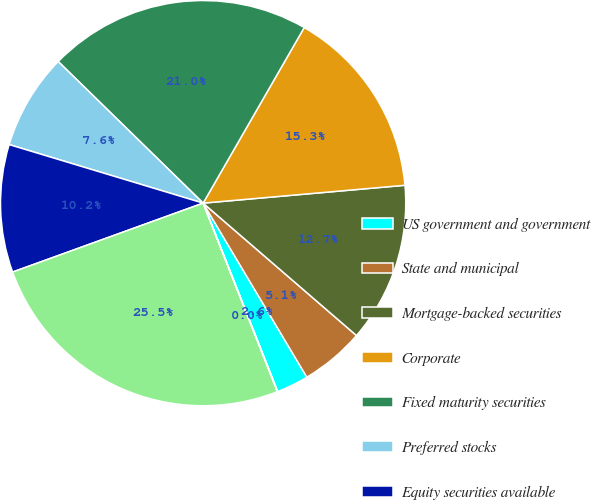<chart> <loc_0><loc_0><loc_500><loc_500><pie_chart><fcel>US government and government<fcel>State and municipal<fcel>Mortgage-backed securities<fcel>Corporate<fcel>Fixed maturity securities<fcel>Preferred stocks<fcel>Equity securities available<fcel>Total<fcel>Foreign government<nl><fcel>2.56%<fcel>5.11%<fcel>12.74%<fcel>15.28%<fcel>21.0%<fcel>7.65%<fcel>10.19%<fcel>25.45%<fcel>0.02%<nl></chart> 